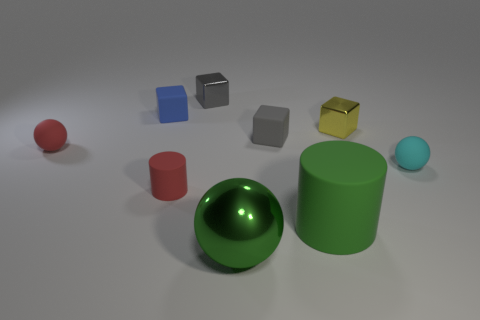Subtract all large green shiny spheres. How many spheres are left? 2 Subtract all gray blocks. How many blocks are left? 2 Subtract all blocks. How many objects are left? 5 Subtract 2 spheres. How many spheres are left? 1 Subtract 1 cyan spheres. How many objects are left? 8 Subtract all red balls. Subtract all gray cylinders. How many balls are left? 2 Subtract all purple balls. How many brown cubes are left? 0 Subtract all matte balls. Subtract all gray matte objects. How many objects are left? 6 Add 8 metal spheres. How many metal spheres are left? 9 Add 4 blue cubes. How many blue cubes exist? 5 